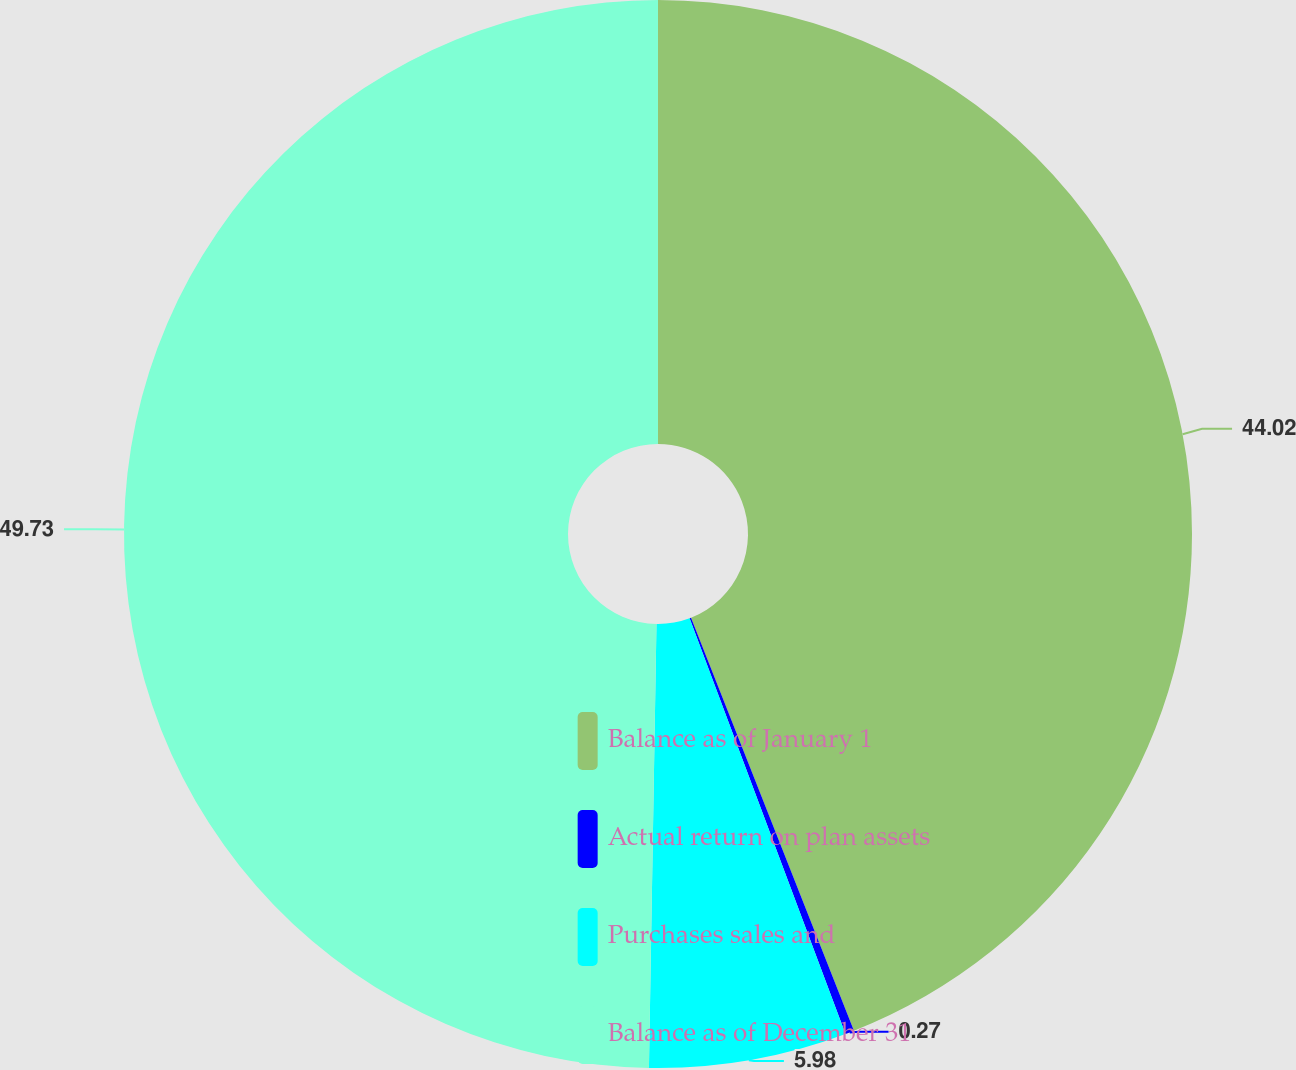Convert chart to OTSL. <chart><loc_0><loc_0><loc_500><loc_500><pie_chart><fcel>Balance as of January 1<fcel>Actual return on plan assets<fcel>Purchases sales and<fcel>Balance as of December 31<nl><fcel>44.02%<fcel>0.27%<fcel>5.98%<fcel>49.73%<nl></chart> 